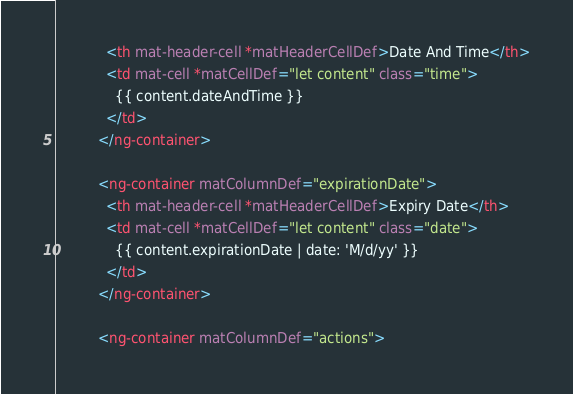<code> <loc_0><loc_0><loc_500><loc_500><_HTML_>            <th mat-header-cell *matHeaderCellDef>Date And Time</th>
            <td mat-cell *matCellDef="let content" class="time">
              {{ content.dateAndTime }}
            </td>
          </ng-container>

          <ng-container matColumnDef="expirationDate">
            <th mat-header-cell *matHeaderCellDef>Expiry Date</th>
            <td mat-cell *matCellDef="let content" class="date">
              {{ content.expirationDate | date: 'M/d/yy' }}
            </td>
          </ng-container>

          <ng-container matColumnDef="actions"></code> 